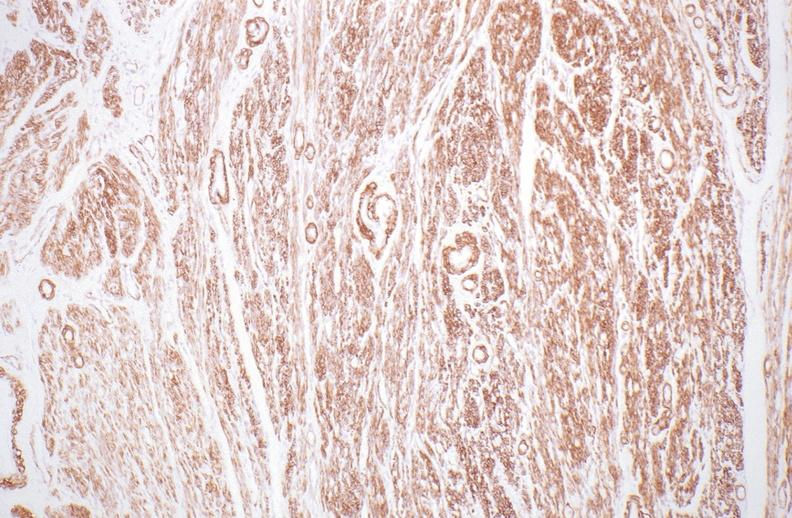s chronic ischemia present?
Answer the question using a single word or phrase. No 